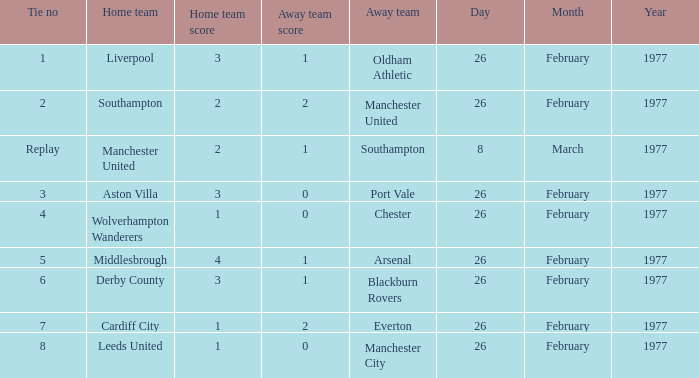Who was the home team that played against Manchester United? Southampton. 